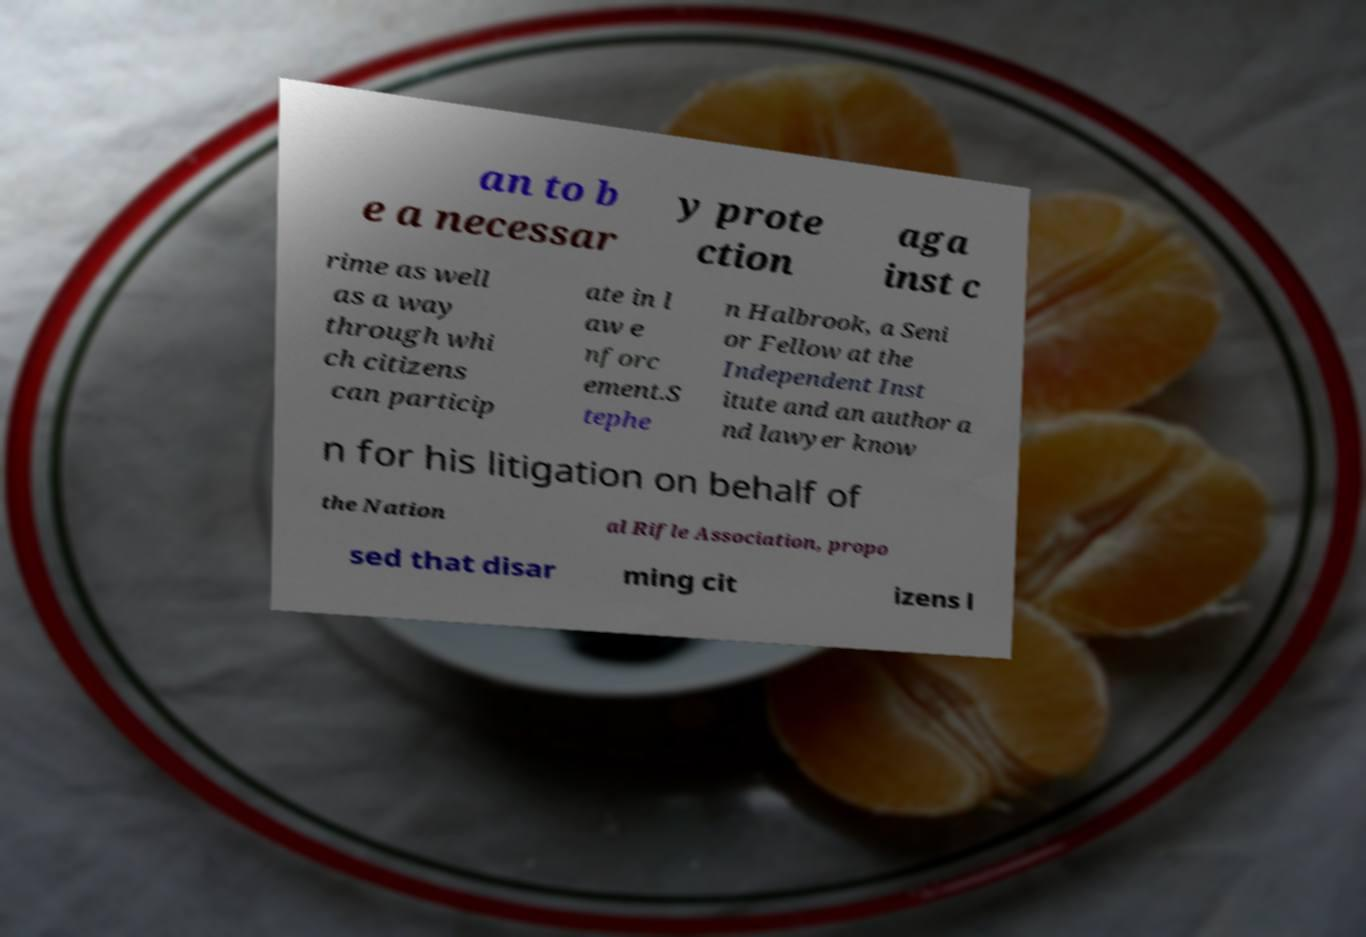Please identify and transcribe the text found in this image. an to b e a necessar y prote ction aga inst c rime as well as a way through whi ch citizens can particip ate in l aw e nforc ement.S tephe n Halbrook, a Seni or Fellow at the Independent Inst itute and an author a nd lawyer know n for his litigation on behalf of the Nation al Rifle Association, propo sed that disar ming cit izens l 